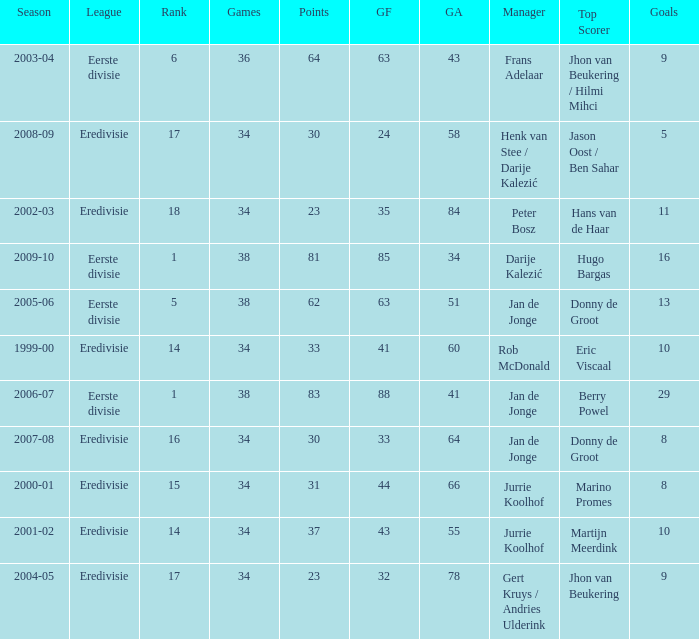Help me parse the entirety of this table. {'header': ['Season', 'League', 'Rank', 'Games', 'Points', 'GF', 'GA', 'Manager', 'Top Scorer', 'Goals'], 'rows': [['2003-04', 'Eerste divisie', '6', '36', '64', '63', '43', 'Frans Adelaar', 'Jhon van Beukering / Hilmi Mihci', '9'], ['2008-09', 'Eredivisie', '17', '34', '30', '24', '58', 'Henk van Stee / Darije Kalezić', 'Jason Oost / Ben Sahar', '5'], ['2002-03', 'Eredivisie', '18', '34', '23', '35', '84', 'Peter Bosz', 'Hans van de Haar', '11'], ['2009-10', 'Eerste divisie', '1', '38', '81', '85', '34', 'Darije Kalezić', 'Hugo Bargas', '16'], ['2005-06', 'Eerste divisie', '5', '38', '62', '63', '51', 'Jan de Jonge', 'Donny de Groot', '13'], ['1999-00', 'Eredivisie', '14', '34', '33', '41', '60', 'Rob McDonald', 'Eric Viscaal', '10'], ['2006-07', 'Eerste divisie', '1', '38', '83', '88', '41', 'Jan de Jonge', 'Berry Powel', '29'], ['2007-08', 'Eredivisie', '16', '34', '30', '33', '64', 'Jan de Jonge', 'Donny de Groot', '8'], ['2000-01', 'Eredivisie', '15', '34', '31', '44', '66', 'Jurrie Koolhof', 'Marino Promes', '8'], ['2001-02', 'Eredivisie', '14', '34', '37', '43', '55', 'Jurrie Koolhof', 'Martijn Meerdink', '10'], ['2004-05', 'Eredivisie', '17', '34', '23', '32', '78', 'Gert Kruys / Andries Ulderink', 'Jhon van Beukering', '9']]} What is the rank of manager Rob Mcdonald? 1.0. 